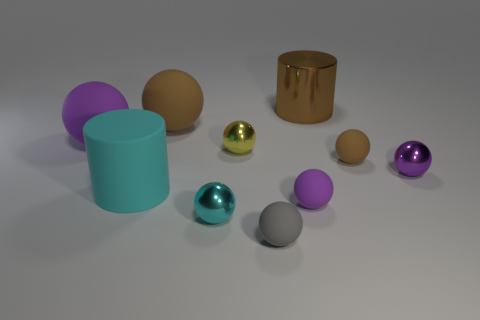Do the metal object right of the brown cylinder and the matte thing to the left of the big cyan object have the same color?
Your response must be concise. Yes. There is a rubber ball that is on the right side of the purple object in front of the large rubber cylinder on the left side of the big brown metal cylinder; what size is it?
Provide a short and direct response. Small. What shape is the purple object that is behind the large matte cylinder and right of the large brown rubber thing?
Keep it short and to the point. Sphere. Is the number of rubber balls that are on the right side of the large brown rubber sphere the same as the number of large cylinders left of the big cyan rubber cylinder?
Give a very brief answer. No. Are there any large cyan spheres made of the same material as the gray thing?
Your response must be concise. No. Is the material of the purple ball left of the small yellow object the same as the tiny cyan object?
Make the answer very short. No. There is a rubber ball that is both in front of the cyan matte cylinder and behind the gray matte thing; what size is it?
Your answer should be very brief. Small. What is the color of the big metal cylinder?
Your answer should be very brief. Brown. What number of tiny yellow things are there?
Keep it short and to the point. 1. What number of things are the same color as the matte cylinder?
Ensure brevity in your answer.  1. 